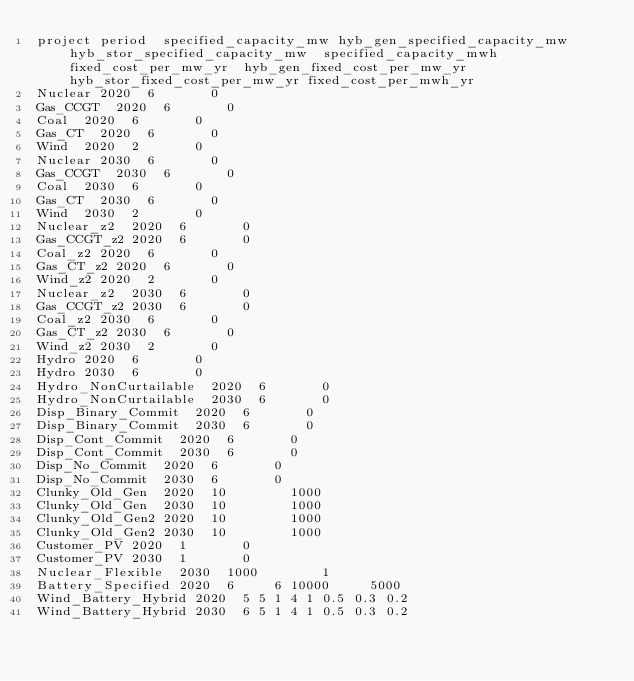<code> <loc_0><loc_0><loc_500><loc_500><_SQL_>project	period	specified_capacity_mw	hyb_gen_specified_capacity_mw	hyb_stor_specified_capacity_mw	specified_capacity_mwh	fixed_cost_per_mw_yr	hyb_gen_fixed_cost_per_mw_yr	hyb_stor_fixed_cost_per_mw_yr	fixed_cost_per_mwh_yr
Nuclear	2020	6				0			
Gas_CCGT	2020	6				0			
Coal	2020	6				0			
Gas_CT	2020	6				0			
Wind	2020	2				0			
Nuclear	2030	6				0			
Gas_CCGT	2030	6				0			
Coal	2030	6				0			
Gas_CT	2030	6				0			
Wind	2030	2				0			
Nuclear_z2	2020	6				0			
Gas_CCGT_z2	2020	6				0			
Coal_z2	2020	6				0			
Gas_CT_z2	2020	6				0			
Wind_z2	2020	2				0			
Nuclear_z2	2030	6				0			
Gas_CCGT_z2	2030	6				0			
Coal_z2	2030	6				0			
Gas_CT_z2	2030	6				0			
Wind_z2	2030	2				0			
Hydro	2020	6				0			
Hydro	2030	6				0			
Hydro_NonCurtailable	2020	6				0			
Hydro_NonCurtailable	2030	6				0			
Disp_Binary_Commit	2020	6				0			
Disp_Binary_Commit	2030	6				0			
Disp_Cont_Commit	2020	6				0			
Disp_Cont_Commit	2030	6				0			
Disp_No_Commit	2020	6				0			
Disp_No_Commit	2030	6				0			
Clunky_Old_Gen	2020	10				1000			
Clunky_Old_Gen	2030	10				1000			
Clunky_Old_Gen2	2020	10				1000			
Clunky_Old_Gen2	2030	10				1000			
Customer_PV	2020	1				0			
Customer_PV	2030	1				0			
Nuclear_Flexible	2030	1000				1			
Battery_Specified	2020	6			6	10000			5000
Wind_Battery_Hybrid	2020	5	5	1	4	1	0.5	0.3	0.2
Wind_Battery_Hybrid	2030	6	5	1	4	1	0.5	0.3	0.2</code> 